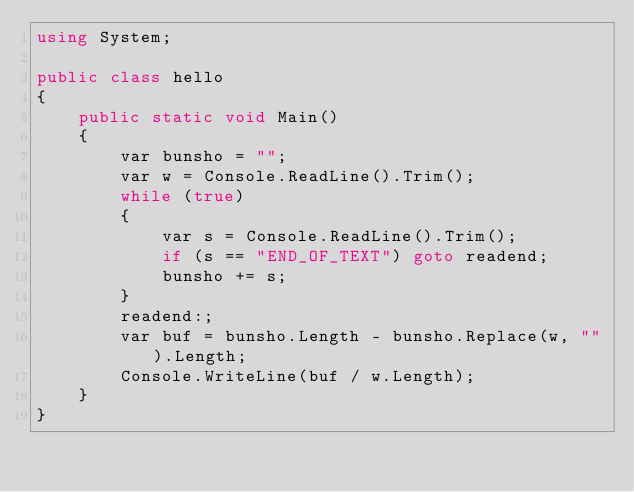Convert code to text. <code><loc_0><loc_0><loc_500><loc_500><_C#_>using System;

public class hello
{
    public static void Main()
    {
        var bunsho = "";
        var w = Console.ReadLine().Trim();
        while (true)
        {
            var s = Console.ReadLine().Trim();
            if (s == "END_OF_TEXT") goto readend;
            bunsho += s;
        }
        readend:;
        var buf = bunsho.Length - bunsho.Replace(w, "").Length;
        Console.WriteLine(buf / w.Length);
    }
}</code> 